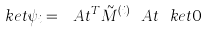Convert formula to latex. <formula><loc_0><loc_0><loc_500><loc_500>\ k e t { \psi _ { i } } = \ A t ^ { T } \tilde { M } ^ { ( i ) } \ A t \ k e t { 0 }</formula> 